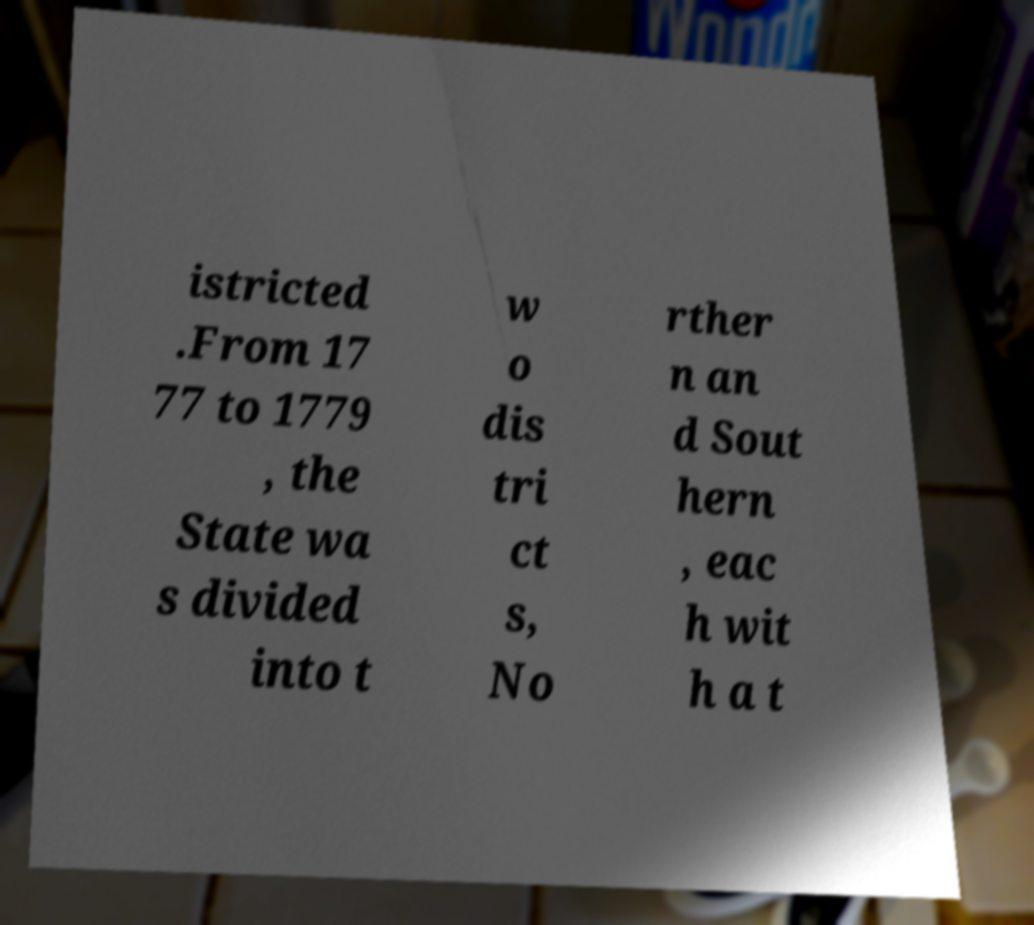For documentation purposes, I need the text within this image transcribed. Could you provide that? istricted .From 17 77 to 1779 , the State wa s divided into t w o dis tri ct s, No rther n an d Sout hern , eac h wit h a t 